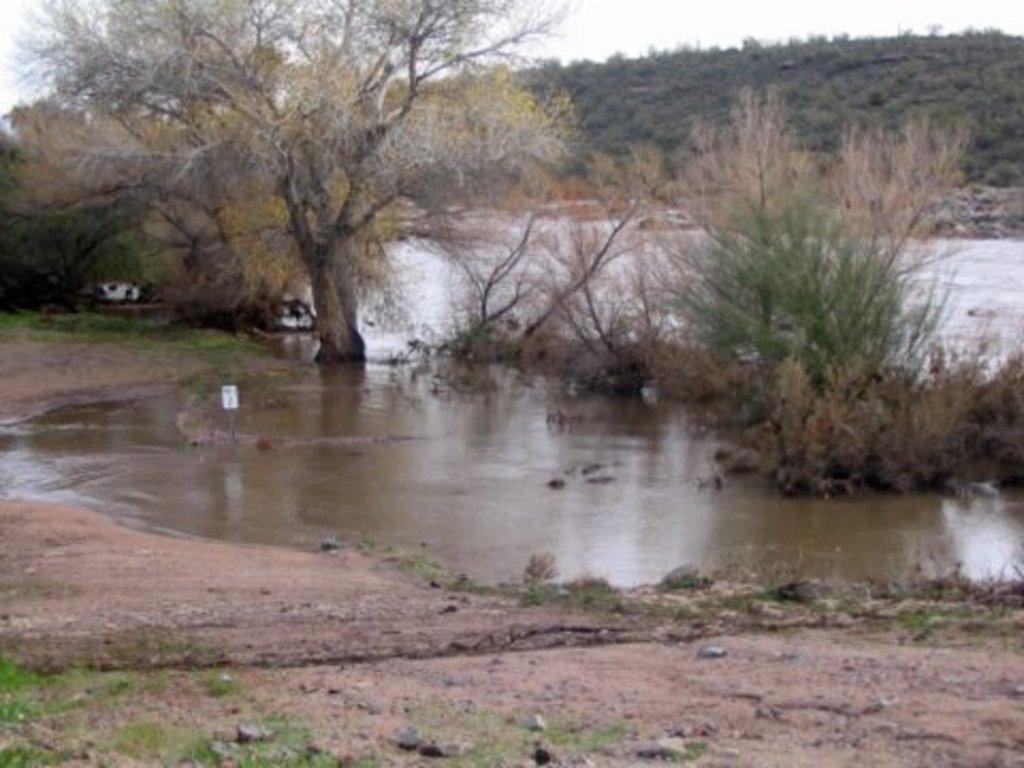Please provide a concise description of this image. In this picture we can see stones on the ground, water, trees, plants and in the background we can see the sky. 